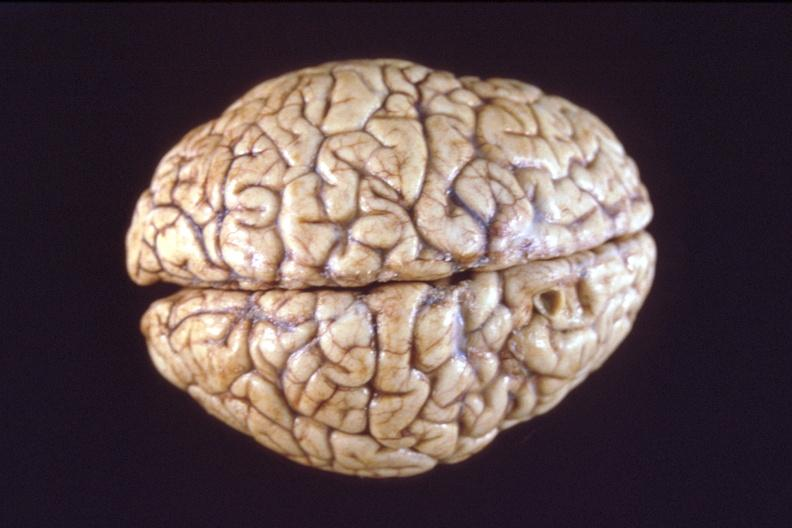what is present?
Answer the question using a single word or phrase. Nervous 